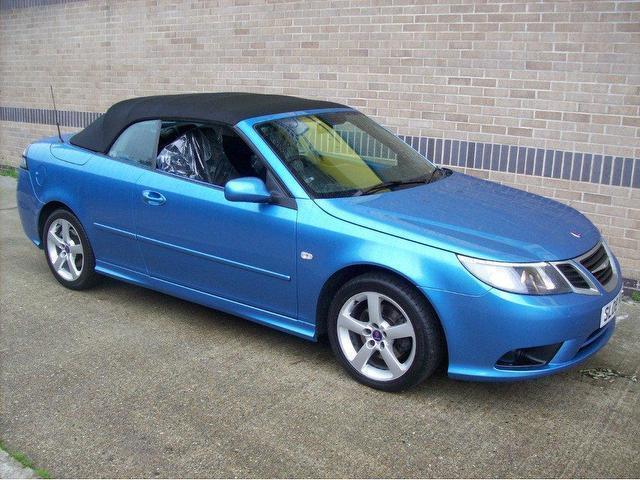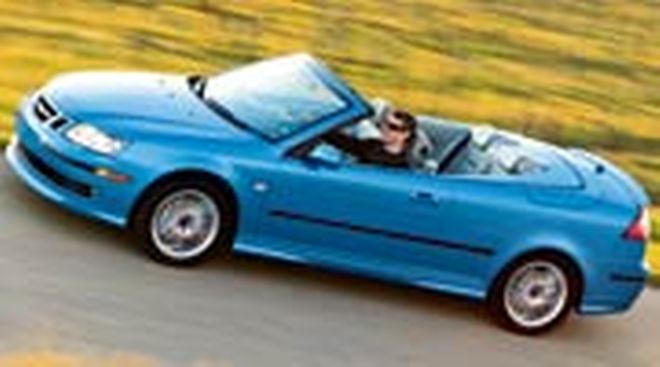The first image is the image on the left, the second image is the image on the right. Assess this claim about the two images: "The convertible in the right image has its top off.". Correct or not? Answer yes or no. Yes. The first image is the image on the left, the second image is the image on the right. For the images displayed, is the sentence "Each image shows a grey convertible." factually correct? Answer yes or no. No. 